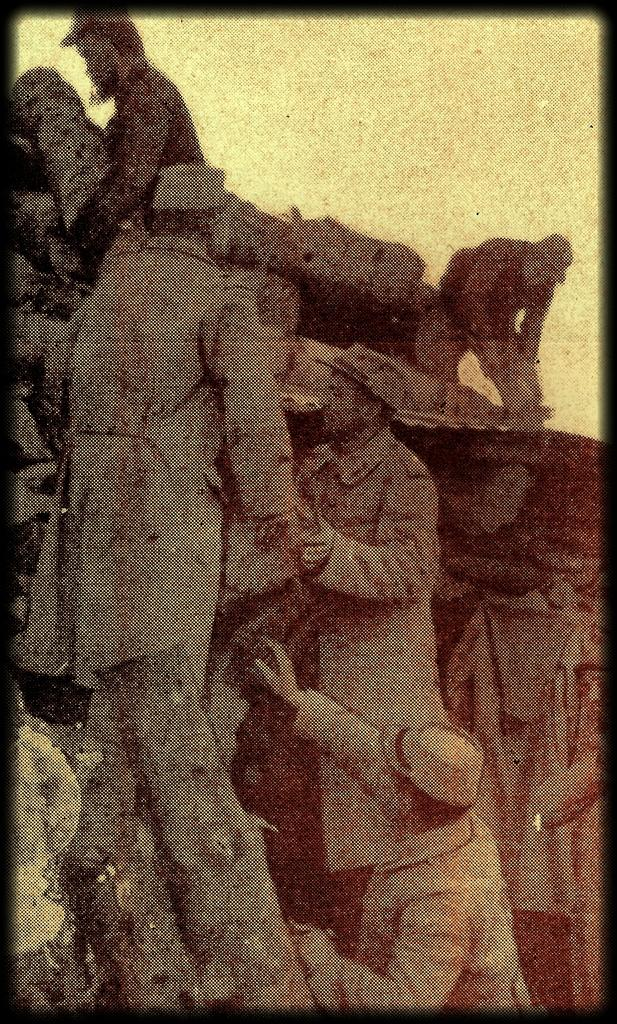How many people are in the image? There are a few persons in the image. What type of clothing are the persons wearing? The persons are wearing coats. What is on the heads of the persons in the image? The persons have caps on their heads. What type of rat is visible in the image? There is no rat present in the image. What type of silk material is used in the caps worn by the persons in the image? The provided facts do not mention any specific materials used in the caps, so we cannot determine if silk is used. 